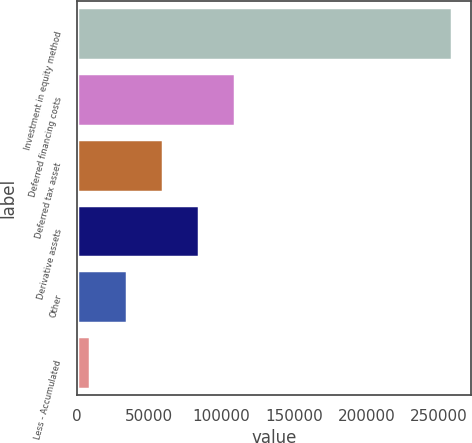Convert chart to OTSL. <chart><loc_0><loc_0><loc_500><loc_500><bar_chart><fcel>Investment in equity method<fcel>Deferred financing costs<fcel>Deferred tax asset<fcel>Derivative assets<fcel>Other<fcel>Less - Accumulated<nl><fcel>259181<fcel>109308<fcel>59349.8<fcel>84328.7<fcel>34370.9<fcel>9392<nl></chart> 